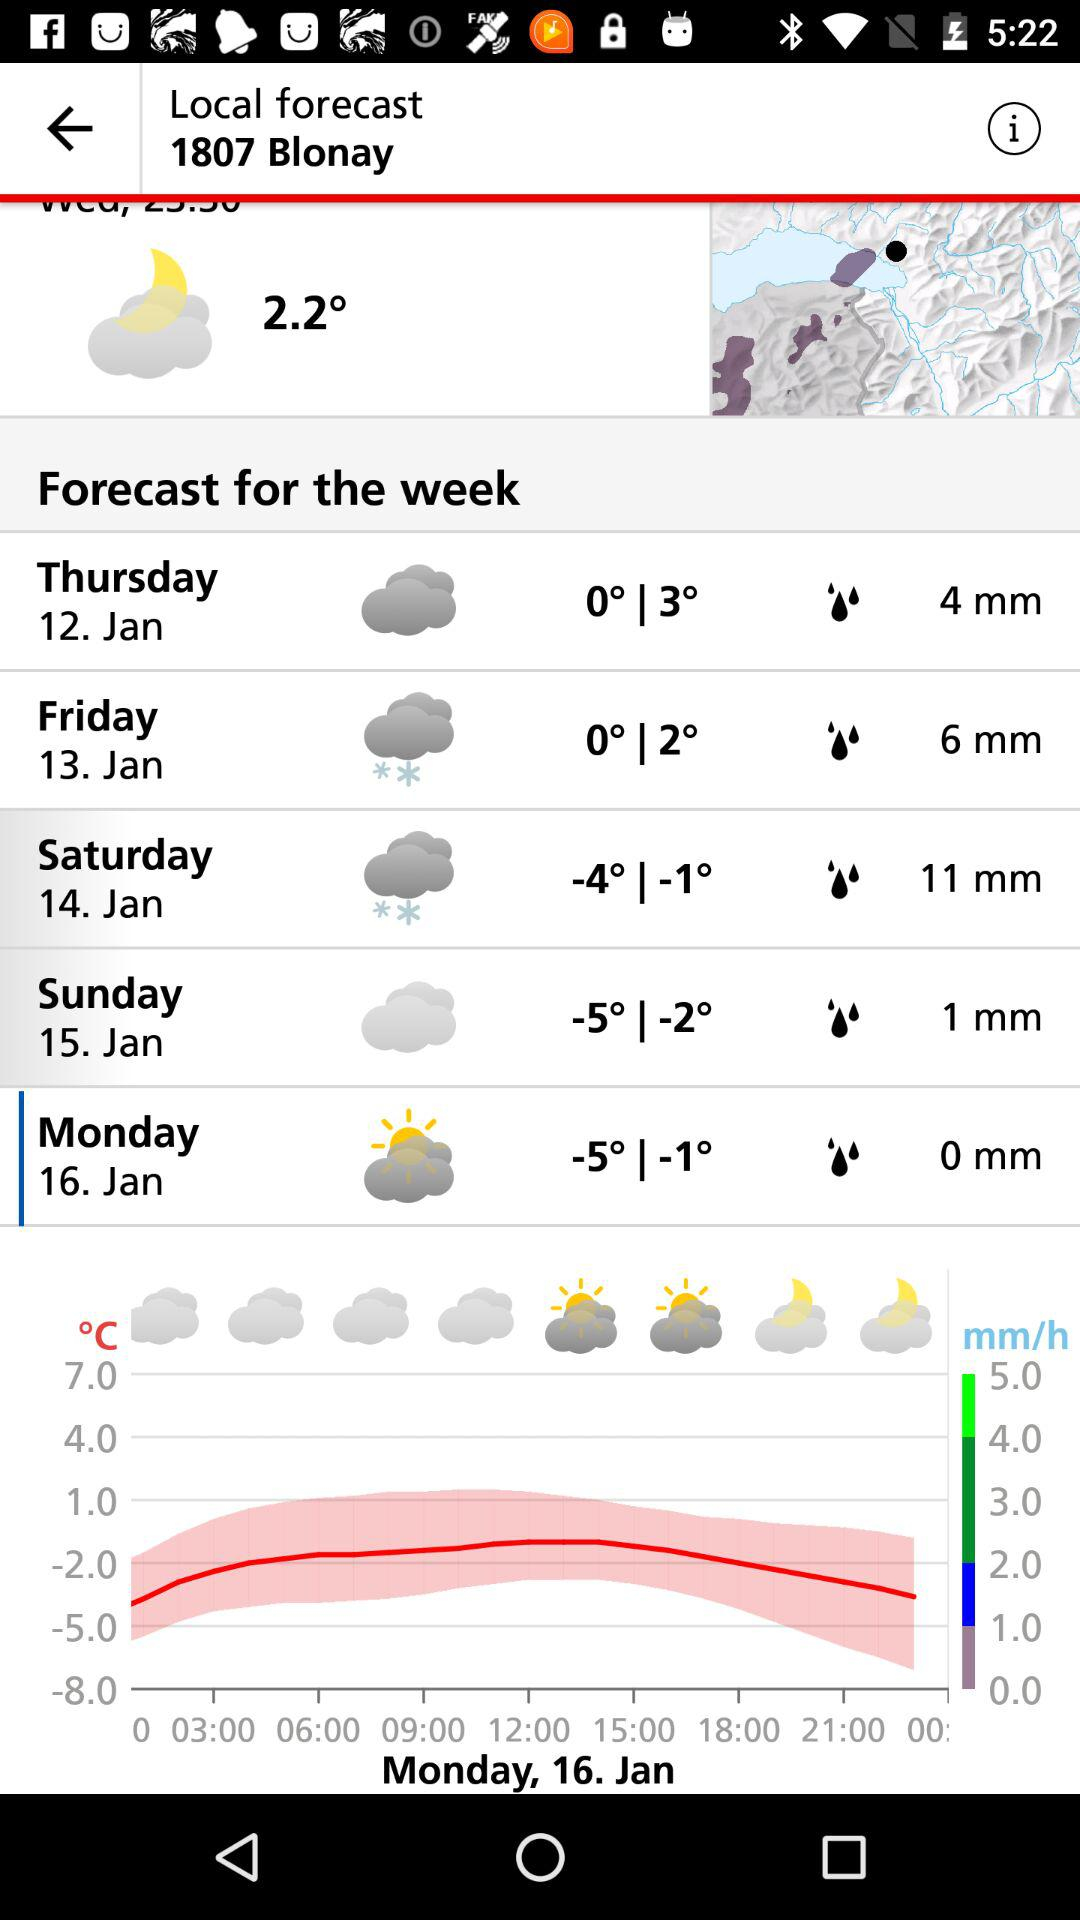How much rain is expected to fall on Thursday?
Answer the question using a single word or phrase. 4 mm 